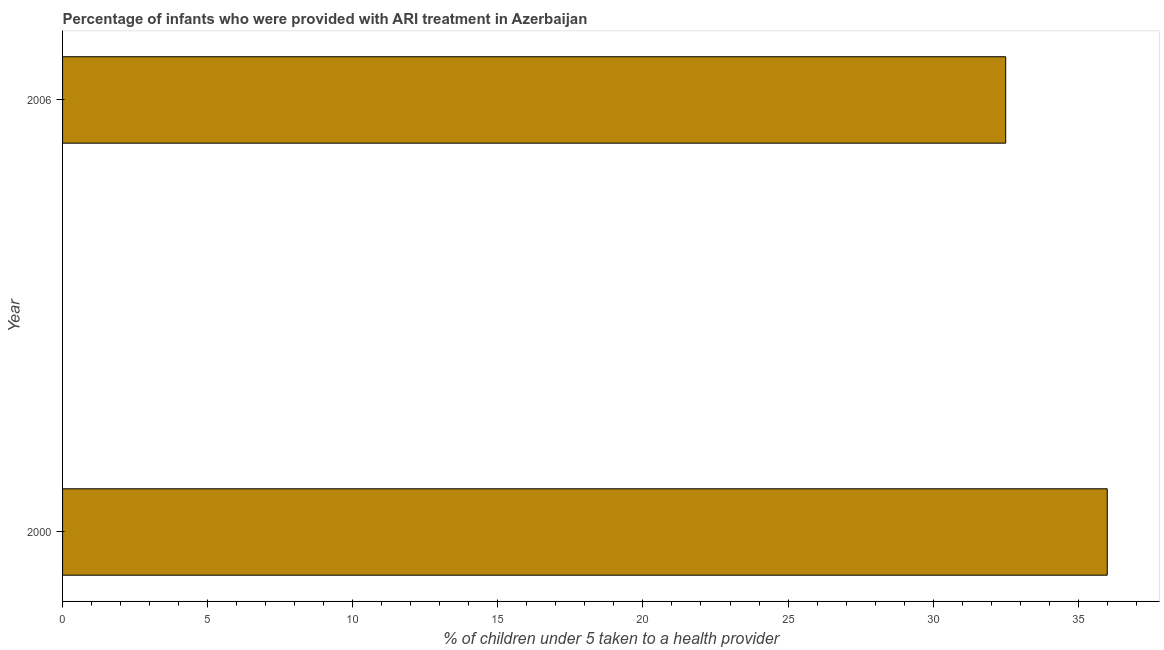What is the title of the graph?
Your answer should be compact. Percentage of infants who were provided with ARI treatment in Azerbaijan. What is the label or title of the X-axis?
Provide a short and direct response. % of children under 5 taken to a health provider. What is the label or title of the Y-axis?
Give a very brief answer. Year. What is the percentage of children who were provided with ari treatment in 2000?
Your answer should be very brief. 36. Across all years, what is the maximum percentage of children who were provided with ari treatment?
Offer a very short reply. 36. Across all years, what is the minimum percentage of children who were provided with ari treatment?
Provide a short and direct response. 32.5. In which year was the percentage of children who were provided with ari treatment maximum?
Ensure brevity in your answer.  2000. In which year was the percentage of children who were provided with ari treatment minimum?
Offer a very short reply. 2006. What is the sum of the percentage of children who were provided with ari treatment?
Your answer should be very brief. 68.5. What is the difference between the percentage of children who were provided with ari treatment in 2000 and 2006?
Your response must be concise. 3.5. What is the average percentage of children who were provided with ari treatment per year?
Provide a succinct answer. 34.25. What is the median percentage of children who were provided with ari treatment?
Your response must be concise. 34.25. What is the ratio of the percentage of children who were provided with ari treatment in 2000 to that in 2006?
Provide a succinct answer. 1.11. Is the percentage of children who were provided with ari treatment in 2000 less than that in 2006?
Give a very brief answer. No. In how many years, is the percentage of children who were provided with ari treatment greater than the average percentage of children who were provided with ari treatment taken over all years?
Your response must be concise. 1. How many bars are there?
Offer a terse response. 2. Are all the bars in the graph horizontal?
Keep it short and to the point. Yes. How many years are there in the graph?
Offer a terse response. 2. Are the values on the major ticks of X-axis written in scientific E-notation?
Your answer should be compact. No. What is the % of children under 5 taken to a health provider of 2006?
Offer a very short reply. 32.5. What is the ratio of the % of children under 5 taken to a health provider in 2000 to that in 2006?
Your response must be concise. 1.11. 